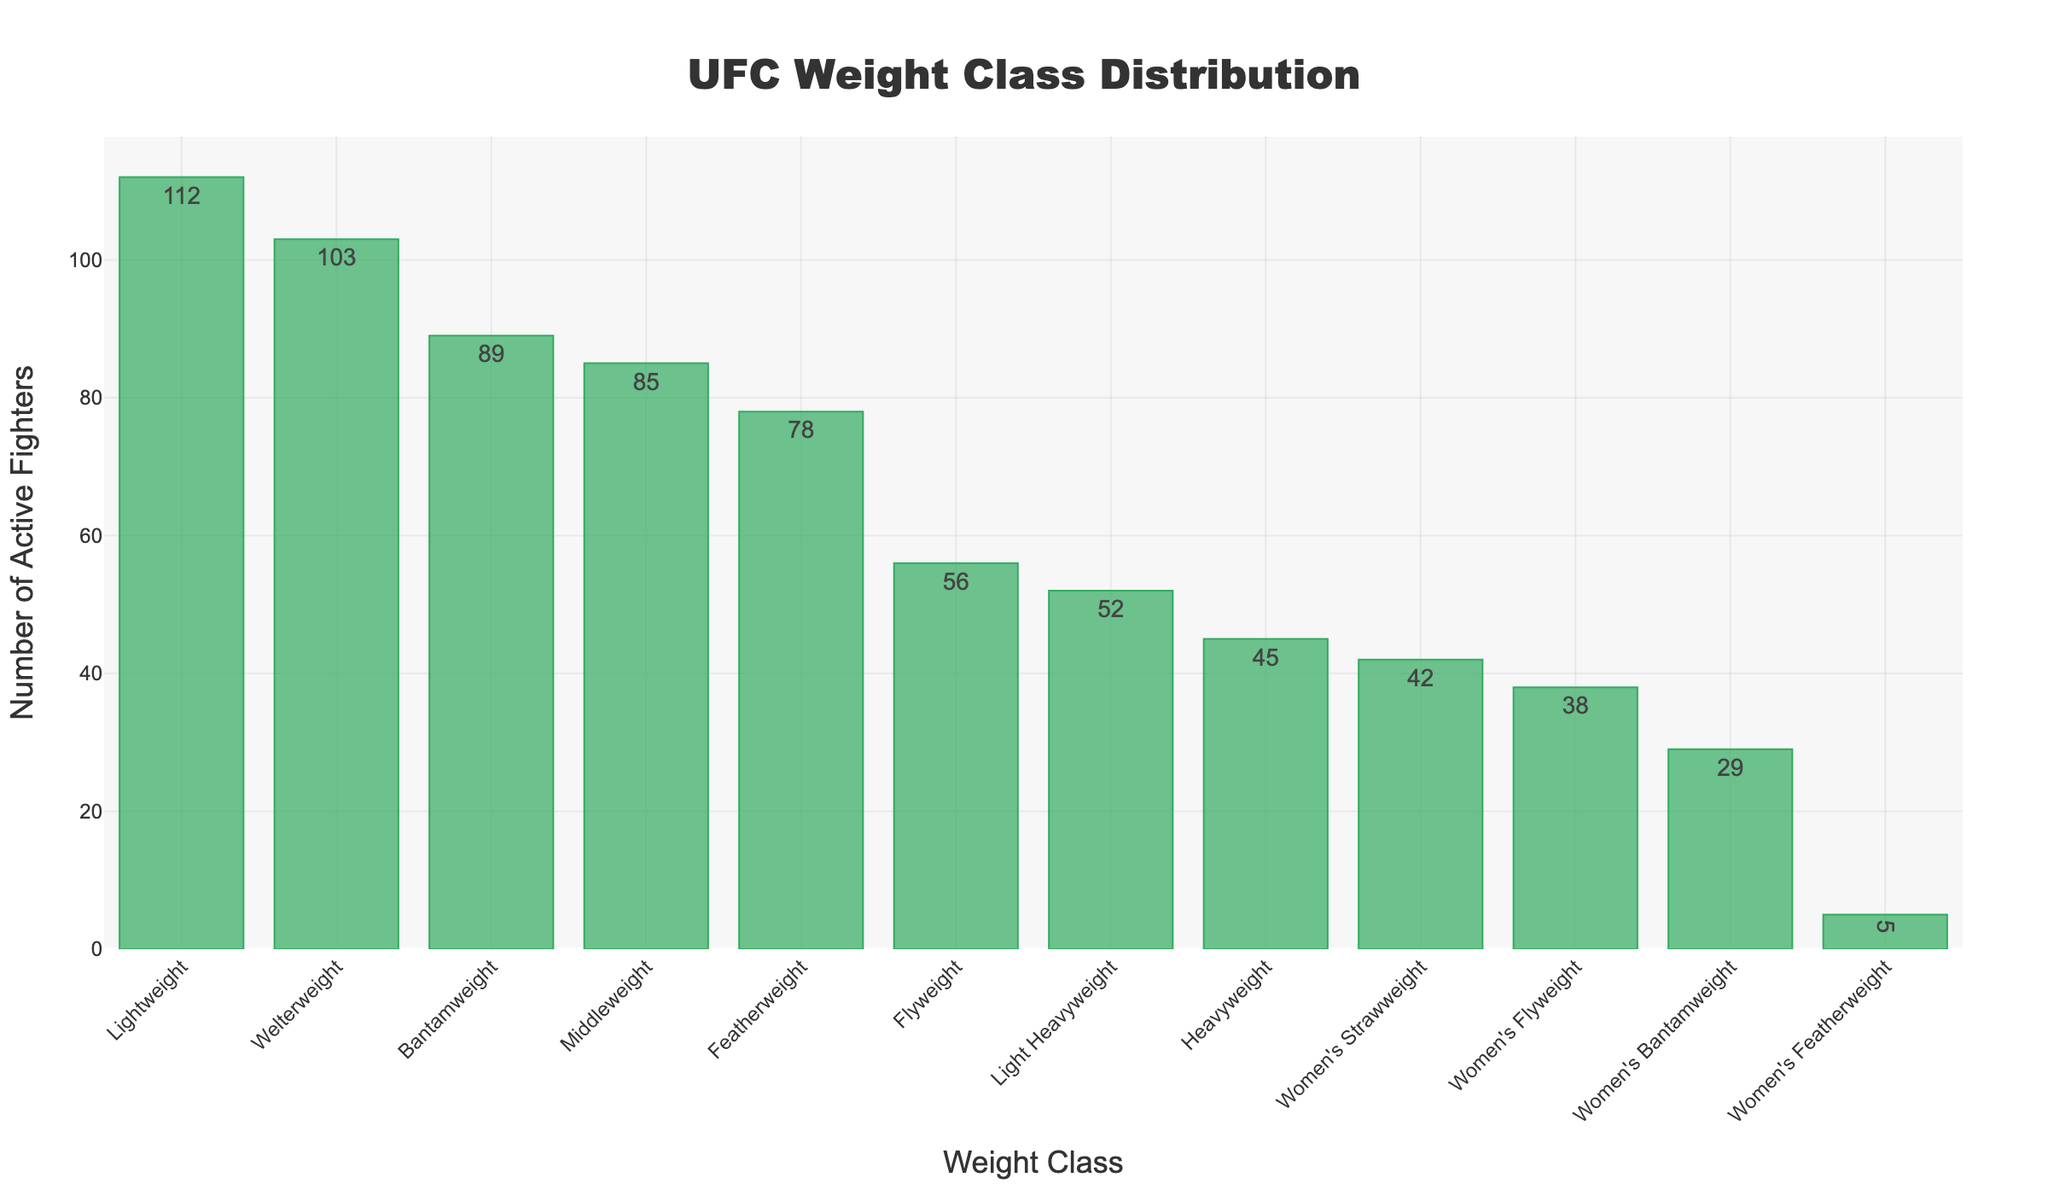What is the weight class with the highest number of active fighters? The bar for the Lightweight division is the tallest, indicating it has the highest number of active fighters.
Answer: Lightweight Which weight class has fewer active fighters, Flyweight or Featherweight? By comparing the height of the bars, the Flyweight class is shorter than the Featherweight class.
Answer: Flyweight What is the difference in the number of active fighters between the Welterweight and Middleweight classes? The number of active fighters for the Welterweight class is 103 and for the Middleweight class is 85. The difference is 103 - 85 = 18.
Answer: 18 How many more active fighters are in the Bantamweight class compared to the Women's Flyweight class? The Bantamweight class has 89 active fighters, while the Women's Flyweight class has 38. The difference is 89 - 38 = 51.
Answer: 51 What is the total number of active male fighters across all weight classes? Add the number of active fighters in each male weight class: 56 (Flyweight) + 89 (Bantamweight) + 78 (Featherweight) + 112 (Lightweight) + 103 (Welterweight) + 85 (Middleweight) + 52 (Light Heavyweight) + 45 (Heavyweight) = 620.
Answer: 620 Which women's weight class has the least number of active fighters? The bar for the Women's Featherweight class is the shortest among the women's weight classes.
Answer: Women's Featherweight How does the number of active fighters in the Women's Bantamweight class compare to the Light Heavyweight class? The Women's Bantamweight class has 29 active fighters, while the Light Heavyweight class has 52 active fighters. The Light Heavyweight class has more.
Answer: Light Heavyweight What is the sum of active fighters in the two lightest men's weight classes? Add the number of active fighters in the Flyweight (56) and Bantamweight (89) classes: 56 + 89 = 145.
Answer: 145 What's the difference in the number of active fighters between the class with the most and the class with the least active fighters? The Lightweight class has the most with 112 fighters, and the Women's Featherweight class has the least with 5 fighters. The difference is 112 - 5 = 107.
Answer: 107 What is the average number of active fighters across all weight classes? Add the number of active fighters in each class and divide by the number of classes. Total = 56 + 89 + 78 + 112 + 103 + 85 + 52 + 45 + 42 + 38 + 29 + 5 = 734. There are 12 weight classes, so the average is 734 / 12 ≈ 61.17.
Answer: 61.17 